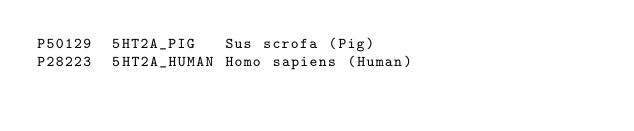<code> <loc_0><loc_0><loc_500><loc_500><_SQL_>P50129	5HT2A_PIG	Sus scrofa (Pig)
P28223	5HT2A_HUMAN	Homo sapiens (Human)
</code> 